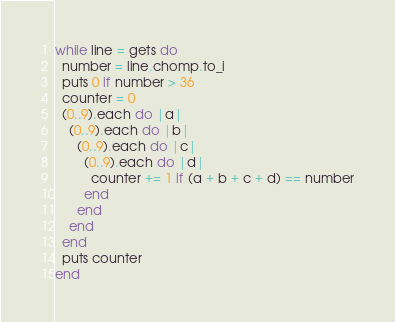<code> <loc_0><loc_0><loc_500><loc_500><_Ruby_>while line = gets do
  number = line.chomp.to_i
  puts 0 if number > 36
  counter = 0
  (0..9).each do |a|
    (0..9).each do |b|
      (0..9).each do |c|
        (0..9).each do |d|
          counter += 1 if (a + b + c + d) == number
        end
      end
    end
  end
  puts counter
end</code> 